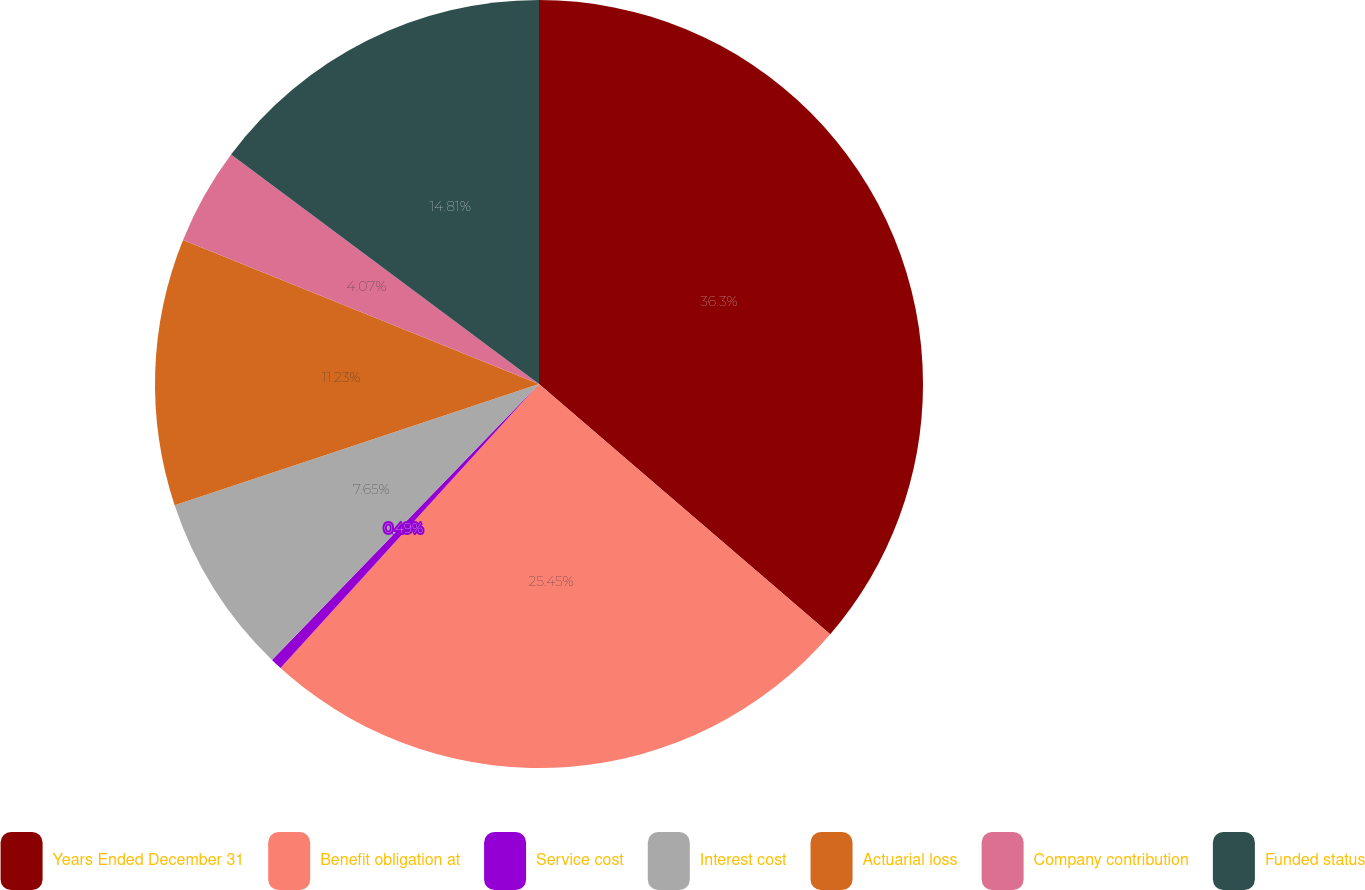Convert chart. <chart><loc_0><loc_0><loc_500><loc_500><pie_chart><fcel>Years Ended December 31<fcel>Benefit obligation at<fcel>Service cost<fcel>Interest cost<fcel>Actuarial loss<fcel>Company contribution<fcel>Funded status<nl><fcel>36.3%<fcel>25.45%<fcel>0.49%<fcel>7.65%<fcel>11.23%<fcel>4.07%<fcel>14.81%<nl></chart> 